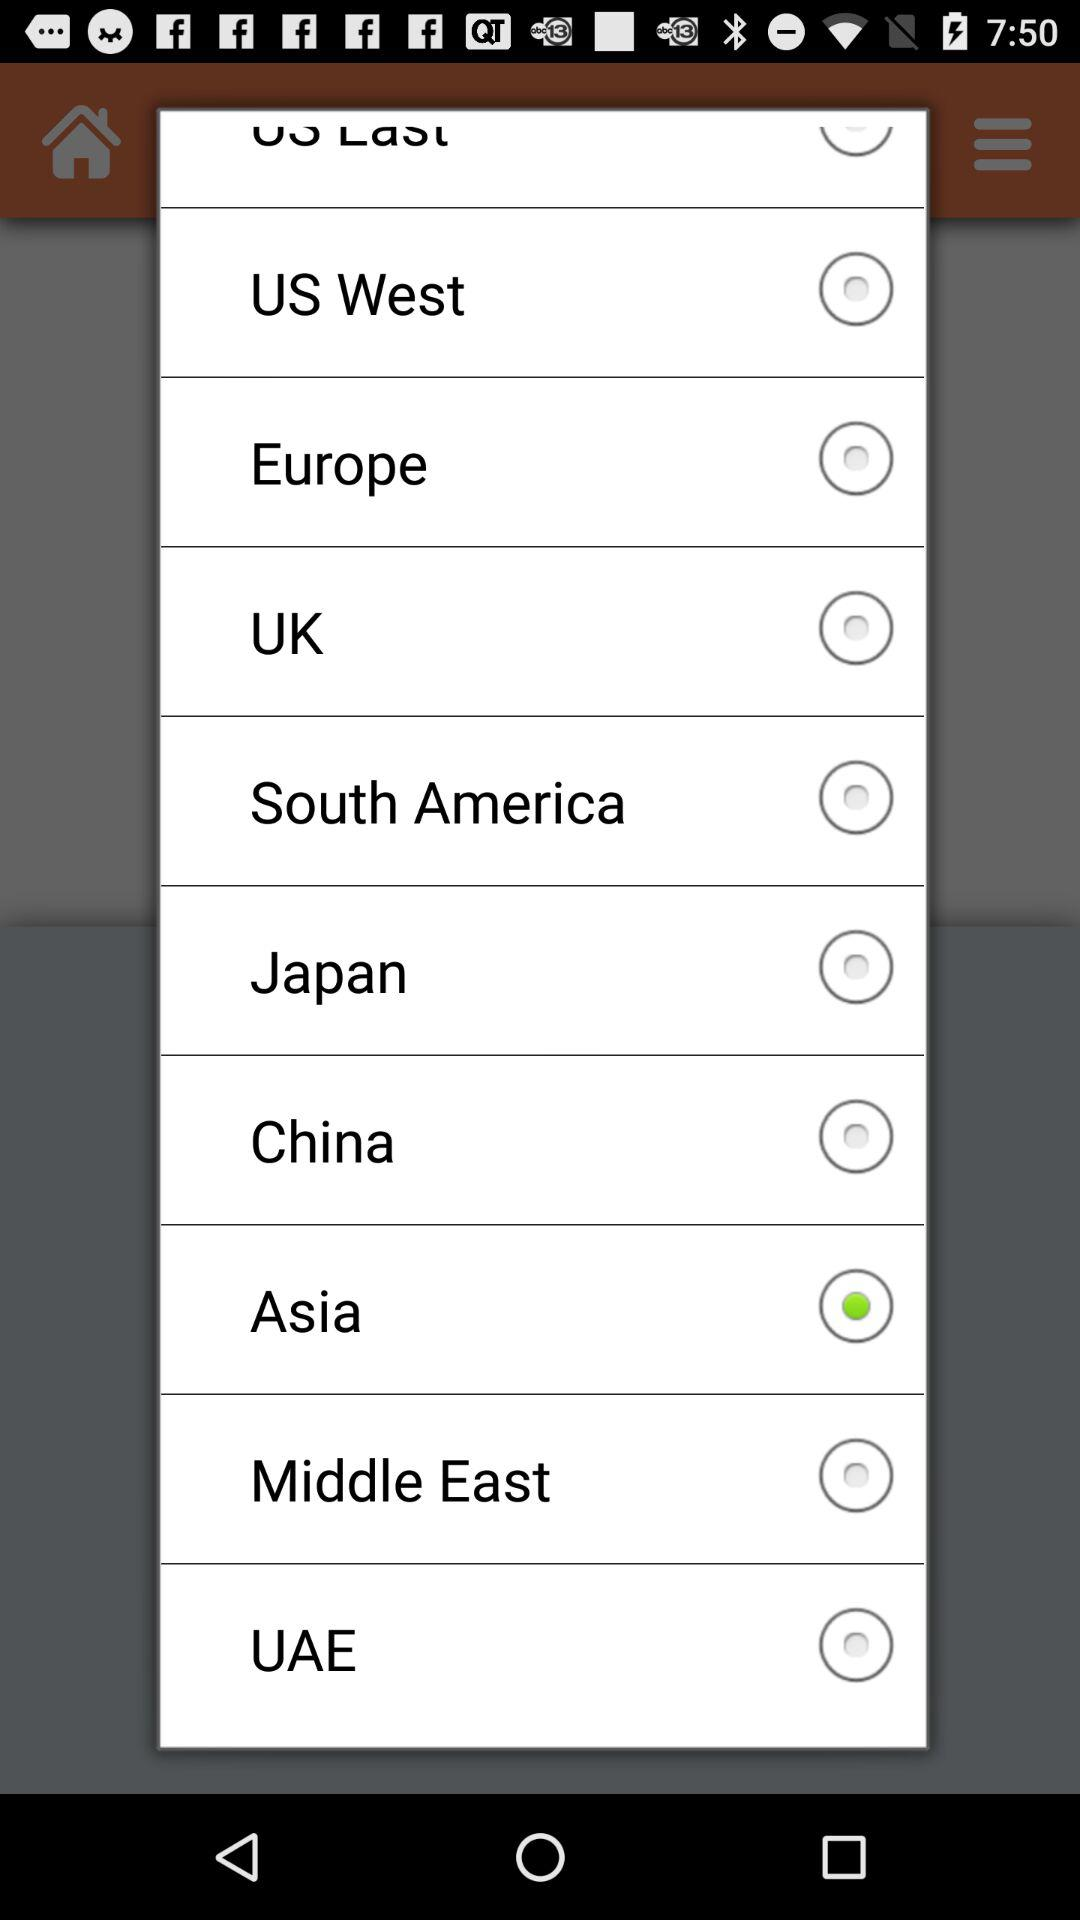What are the options available in the list? The options are US West, Europe, UK, South America, Japan, China, Asia, Middle East and UAE. 